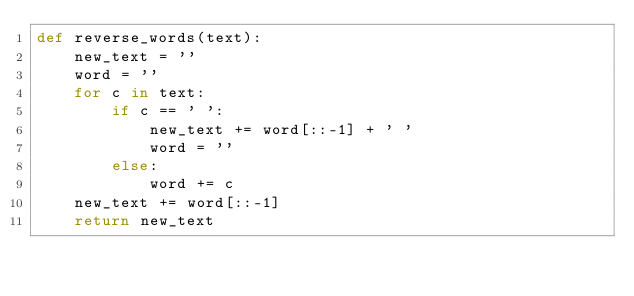<code> <loc_0><loc_0><loc_500><loc_500><_Python_>def reverse_words(text):
    new_text = ''
    word = ''
    for c in text:        
        if c == ' ':
            new_text += word[::-1] + ' '
            word = ''            
        else:
            word += c
    new_text += word[::-1]
    return new_text
            </code> 